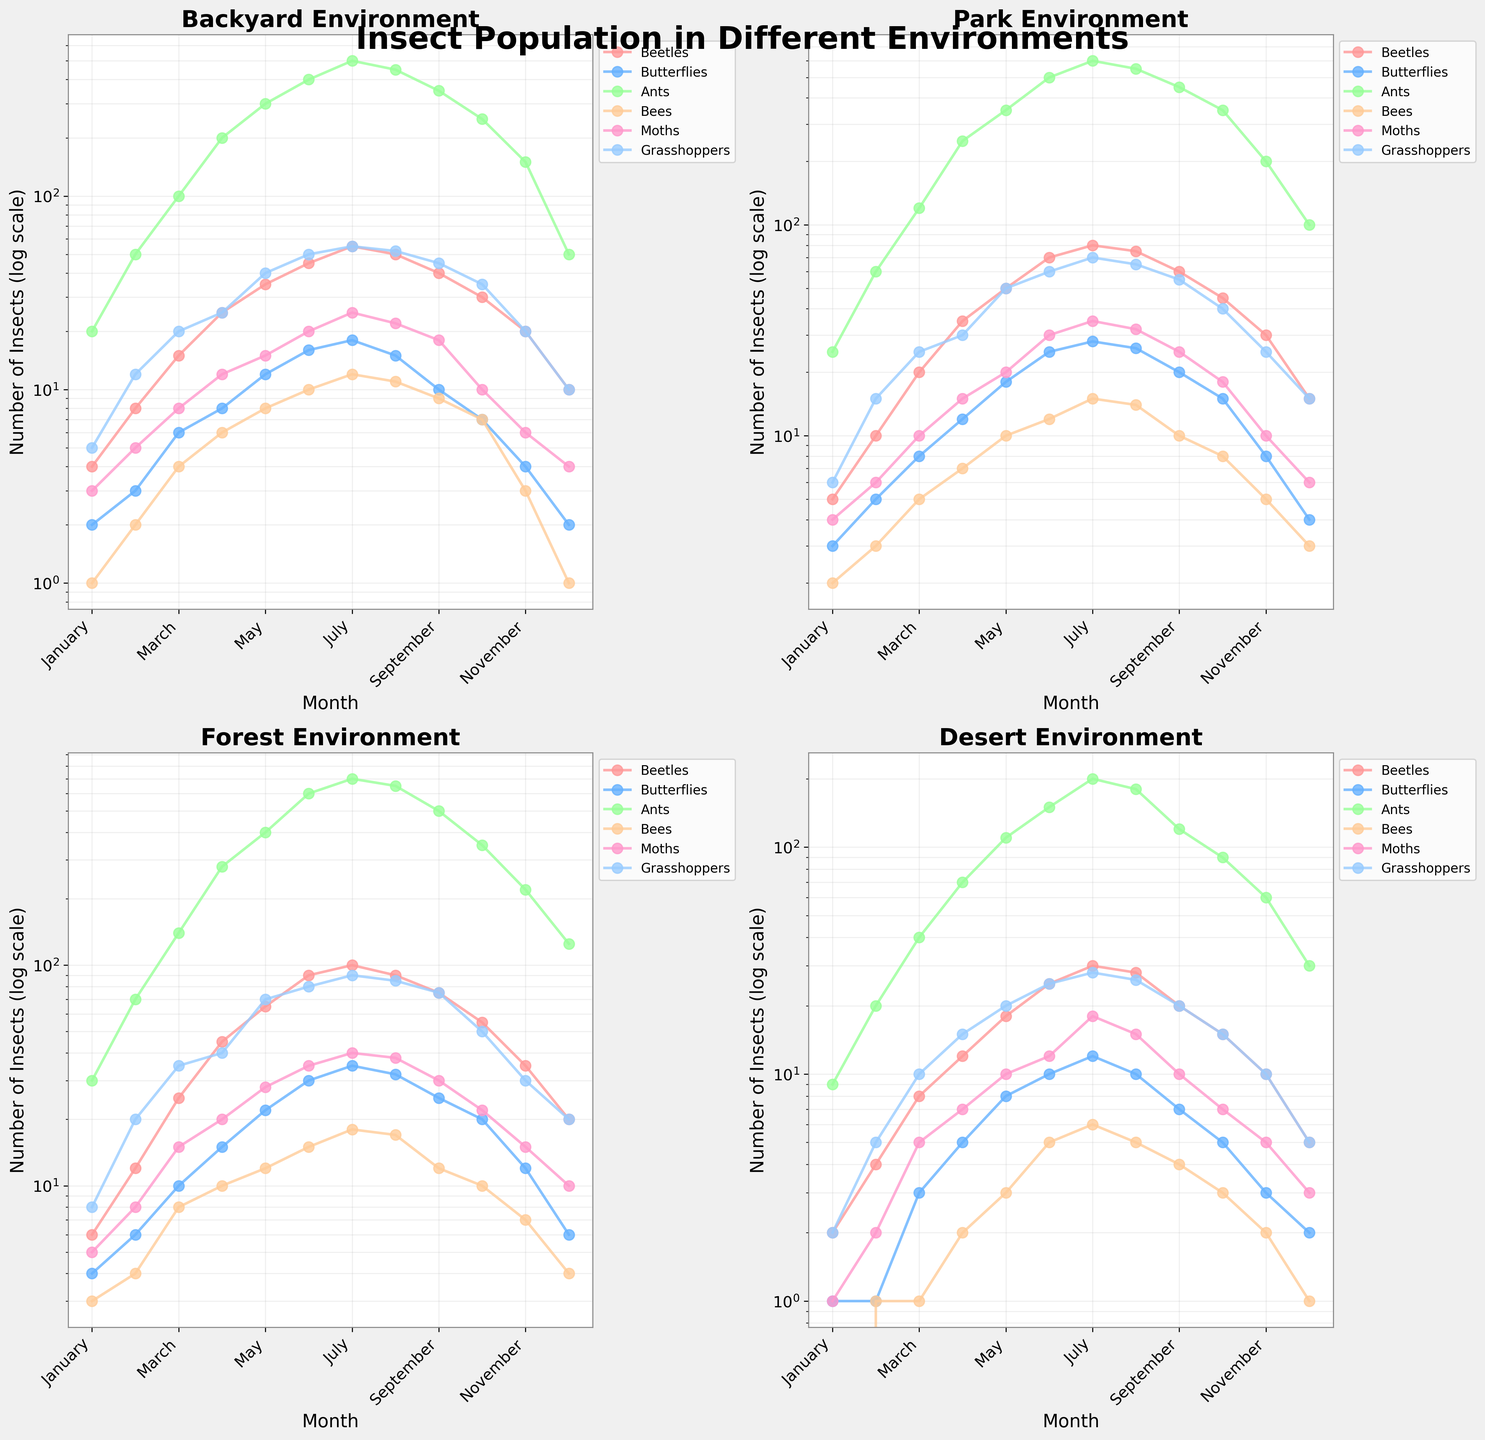What is the title of the figure? The title of the figure is found at the top and it summarizes the content visually. It helps provide context for what the figure represents.
Answer: Insect Population in Different Environments Which month shows the highest number of ants in the forest environment? By focusing on the subplot for the forest environment and comparing the heights of the points for ants, you can identify the month with the highest value.
Answer: July How does the number of beetles in the backyard environment change from January to December? In the backyard subplot, observe the trendline for beetles from January to December. It starts low, increases mid-year, and then decreases again.
Answer: Increases, peaks, then decreases Which environment has the least variation in moth populations over the year? By comparing the amplitude of fluctuations in the moth data points across all subplots, you can identify which environment has the least change.
Answer: Desert How do the fluctuations in butterfly populations compare between backyard and park environments? In subplots for both backyard and park environments, compare the butterfly trendlines. Pay attention to the steepness and frequency of rises and falls.
Answer: Park shows more substantial fluctuations In which environment does the number of grasshoppers reach the highest peak and in which month? Identify the subplot with the highest log-transformed peak for grasshoppers and note the corresponding month.
Answer: Forest, July Compare the number of bees in the desert environment in May and October. Which month has more bees, and by how much? Locate the May and October data points for bees in the desert subplot and compare their values. Calculate the difference between them.
Answer: May, by 7 bees What is the overall trend in the number of insects in the park environment from January to December? Examine the trendlines for all types of insects in the park subplot. Look for general patterns such as increases, peaks, or decreases.
Answer: General increase, peaks mid-year, then decreases What is the difference in the number of beetles between July and August in the forest environment? Find the data points for beetles in July and August in the forest subplot. Subtract the August value from the July value.
Answer: 10 fewer beetles Which environment shows the highest number of butterflies in June and how do the other environments compare in that month? Look at the butterfly data points for June across all subplots and identify the highest value. Then compare values from other subplots for the same month.
Answer: Forest; others are lower 